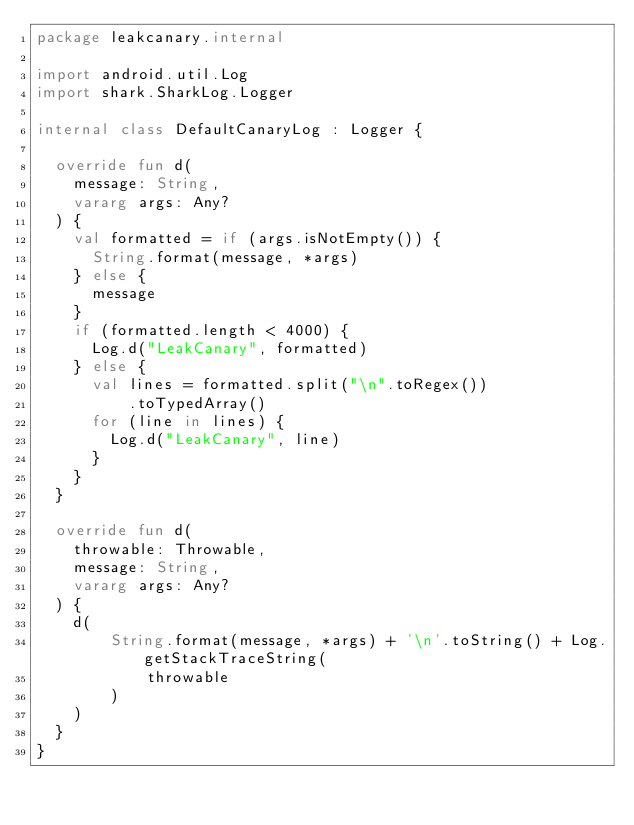Convert code to text. <code><loc_0><loc_0><loc_500><loc_500><_Kotlin_>package leakcanary.internal

import android.util.Log
import shark.SharkLog.Logger

internal class DefaultCanaryLog : Logger {

  override fun d(
    message: String,
    vararg args: Any?
  ) {
    val formatted = if (args.isNotEmpty()) {
      String.format(message, *args)
    } else {
      message
    }
    if (formatted.length < 4000) {
      Log.d("LeakCanary", formatted)
    } else {
      val lines = formatted.split("\n".toRegex())
          .toTypedArray()
      for (line in lines) {
        Log.d("LeakCanary", line)
      }
    }
  }

  override fun d(
    throwable: Throwable,
    message: String,
    vararg args: Any?
  ) {
    d(
        String.format(message, *args) + '\n'.toString() + Log.getStackTraceString(
            throwable
        )
    )
  }
}</code> 